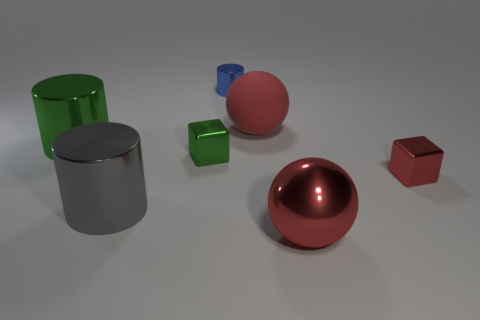Add 2 red balls. How many objects exist? 9 Subtract all cylinders. How many objects are left? 4 Subtract 0 purple cubes. How many objects are left? 7 Subtract all big red metallic balls. Subtract all tiny blue cylinders. How many objects are left? 5 Add 5 big green things. How many big green things are left? 6 Add 2 big gray metal objects. How many big gray metal objects exist? 3 